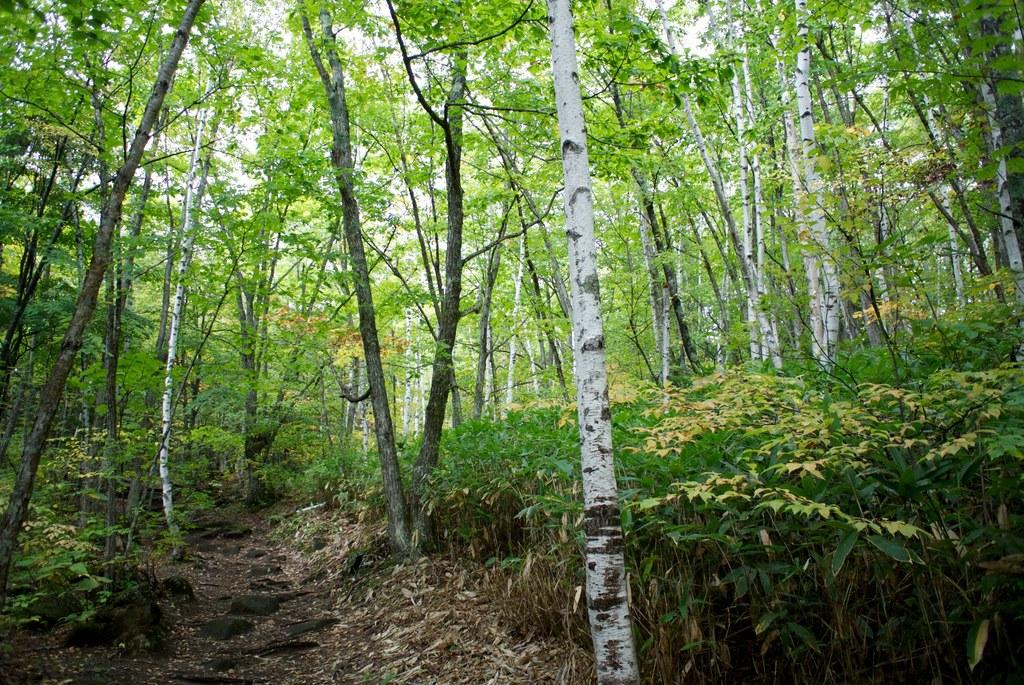What type of vegetation can be seen in the image? There are plants and trees in the image. How are the trees positioned in relation to the sky? The sky is visible through the trees in the image. What color is the sweater worn by the person in the image? There is no person wearing a sweater in the image; it only features plants, trees, and the sky. 